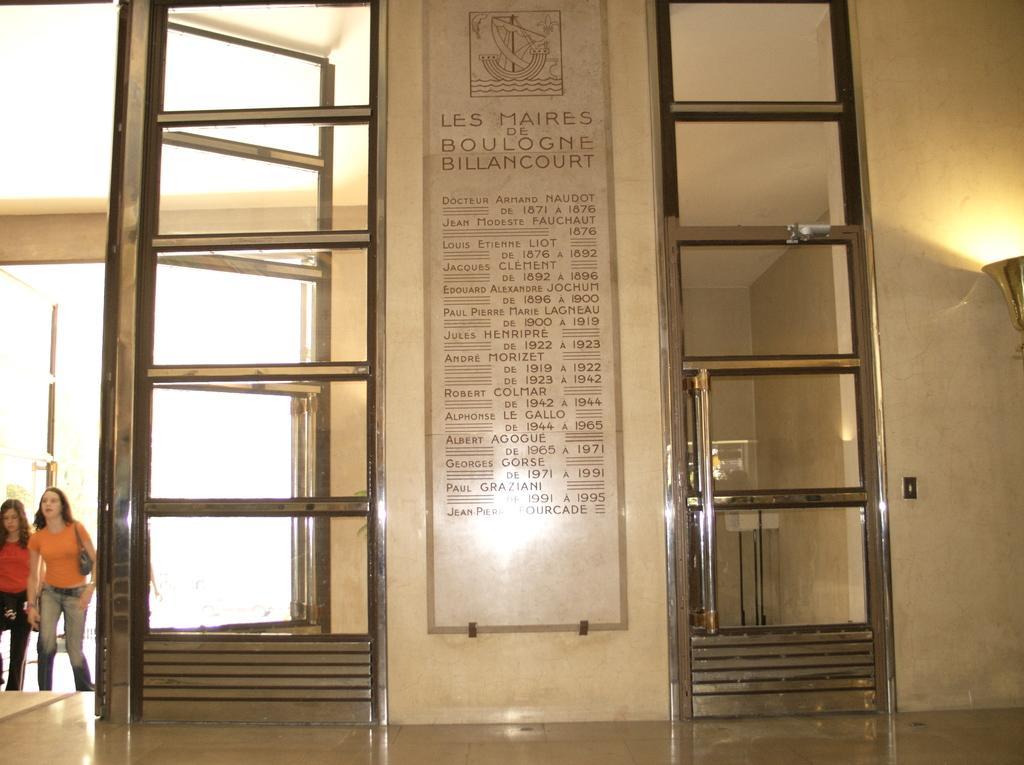Could you give a brief overview of what you see in this image? This image consists of two women walking. In the front, there are doors along with a wall. And there is a board kept on the wall. At the bottom, there is a floor. To the right, there is a lamp. 